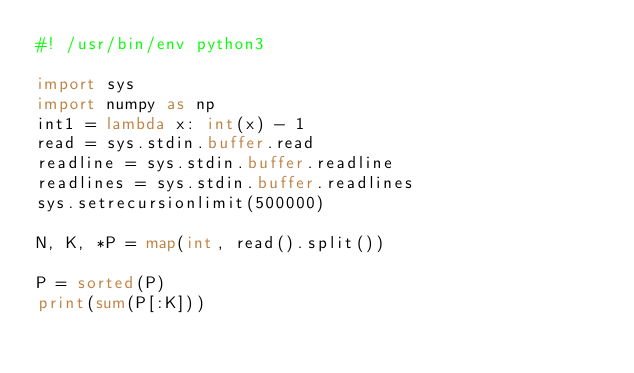<code> <loc_0><loc_0><loc_500><loc_500><_Python_>#! /usr/bin/env python3

import sys
import numpy as np
int1 = lambda x: int(x) - 1
read = sys.stdin.buffer.read
readline = sys.stdin.buffer.readline
readlines = sys.stdin.buffer.readlines
sys.setrecursionlimit(500000)

N, K, *P = map(int, read().split())

P = sorted(P)
print(sum(P[:K]))</code> 